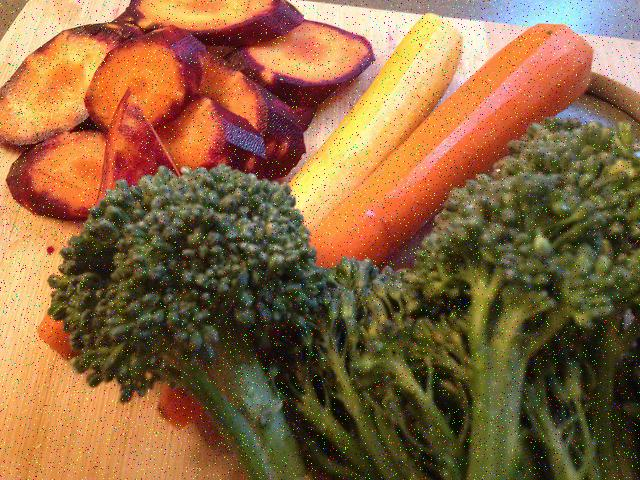Is the image quality poor? The image quality appears to be moderately poor, due to noticeable pixelation and potential compression artifacts, which detract from the clarity of the picture. The colors and details of the vegetables depicted — such as the sliced purple vegetable, the carrots, and the broccoli — are discernible but could be sharper with higher image quality. 